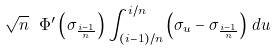<formula> <loc_0><loc_0><loc_500><loc_500>\sqrt { n } \ \Phi ^ { \prime } \left ( \sigma _ { \frac { i - 1 } { n } } \right ) \int _ { ( i - 1 ) / n } ^ { i / n } \left ( \sigma _ { u } - \sigma _ { \frac { i - 1 } { n } } \right ) \, d u</formula> 